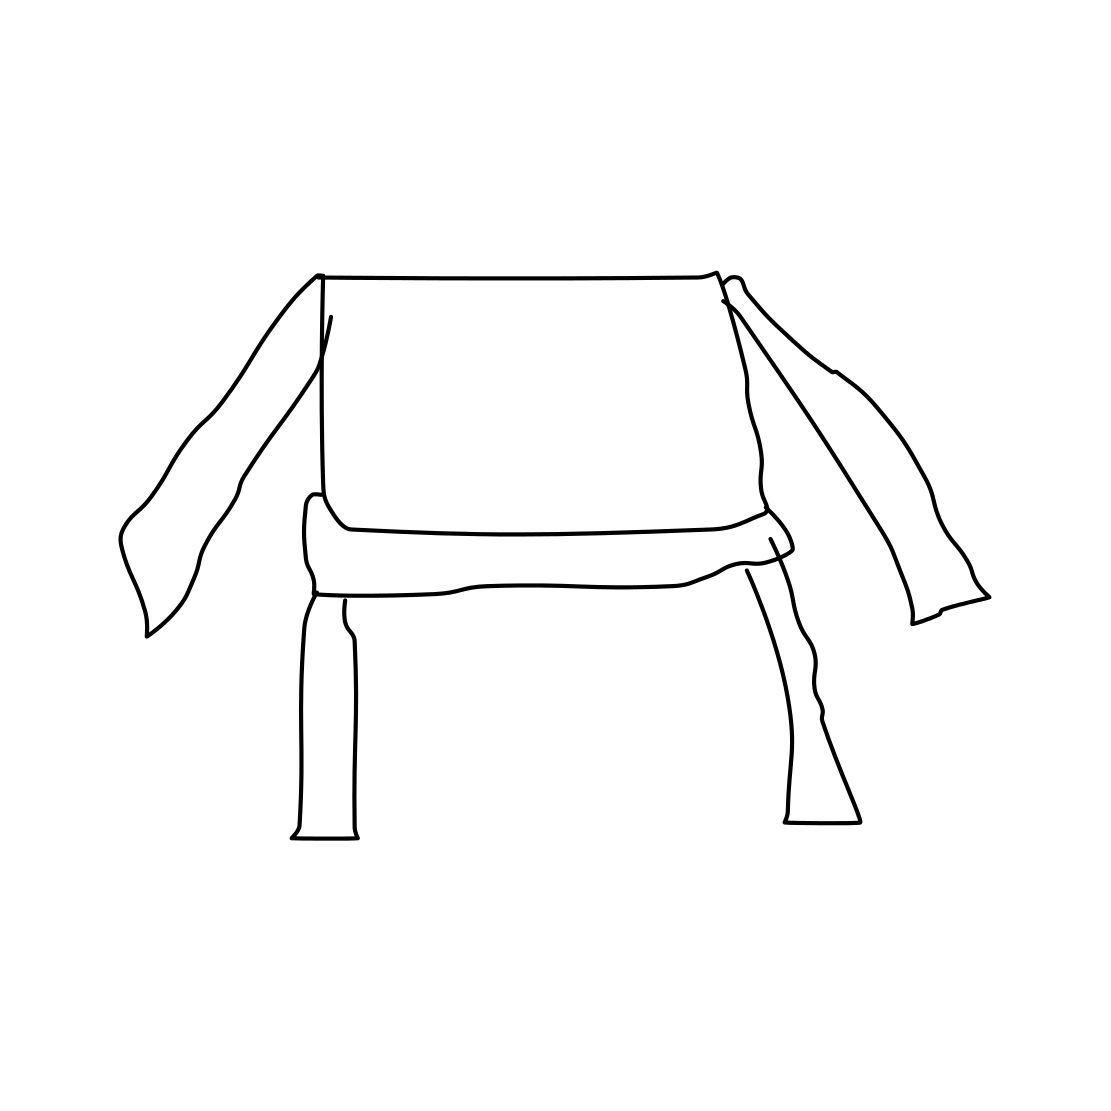Is this a wheelbarrow in the image? The image does not depict a wheelbarrow. What you see is a line drawing of a four-legged object with two appendages that resemble sleeves. It appears to be a stylized representation of a piece of furniture, possibly a chair, with an abstract or minimalist design. 